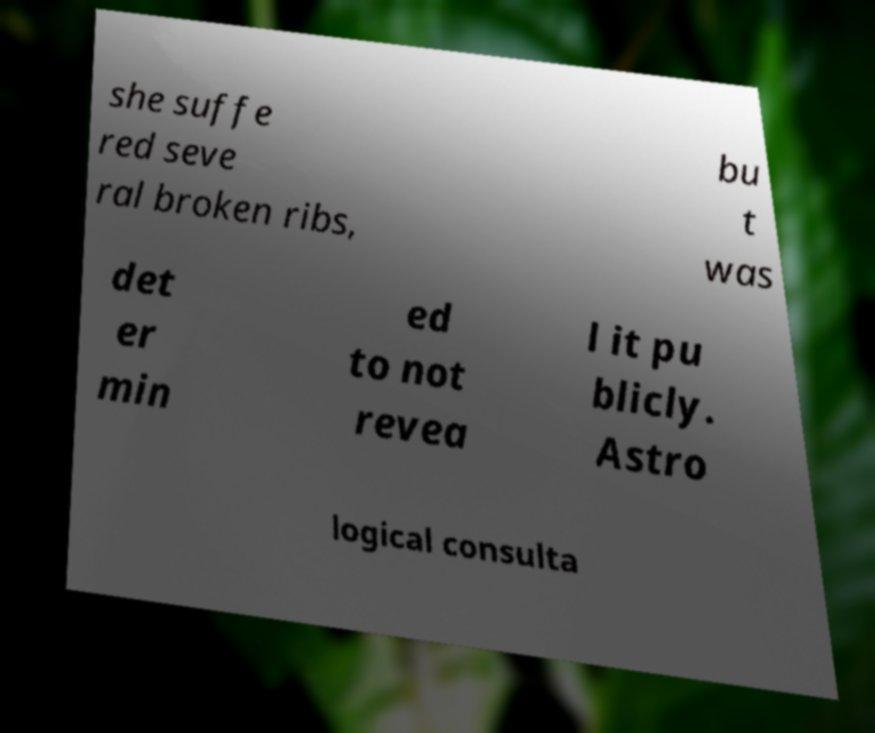What messages or text are displayed in this image? I need them in a readable, typed format. she suffe red seve ral broken ribs, bu t was det er min ed to not revea l it pu blicly. Astro logical consulta 